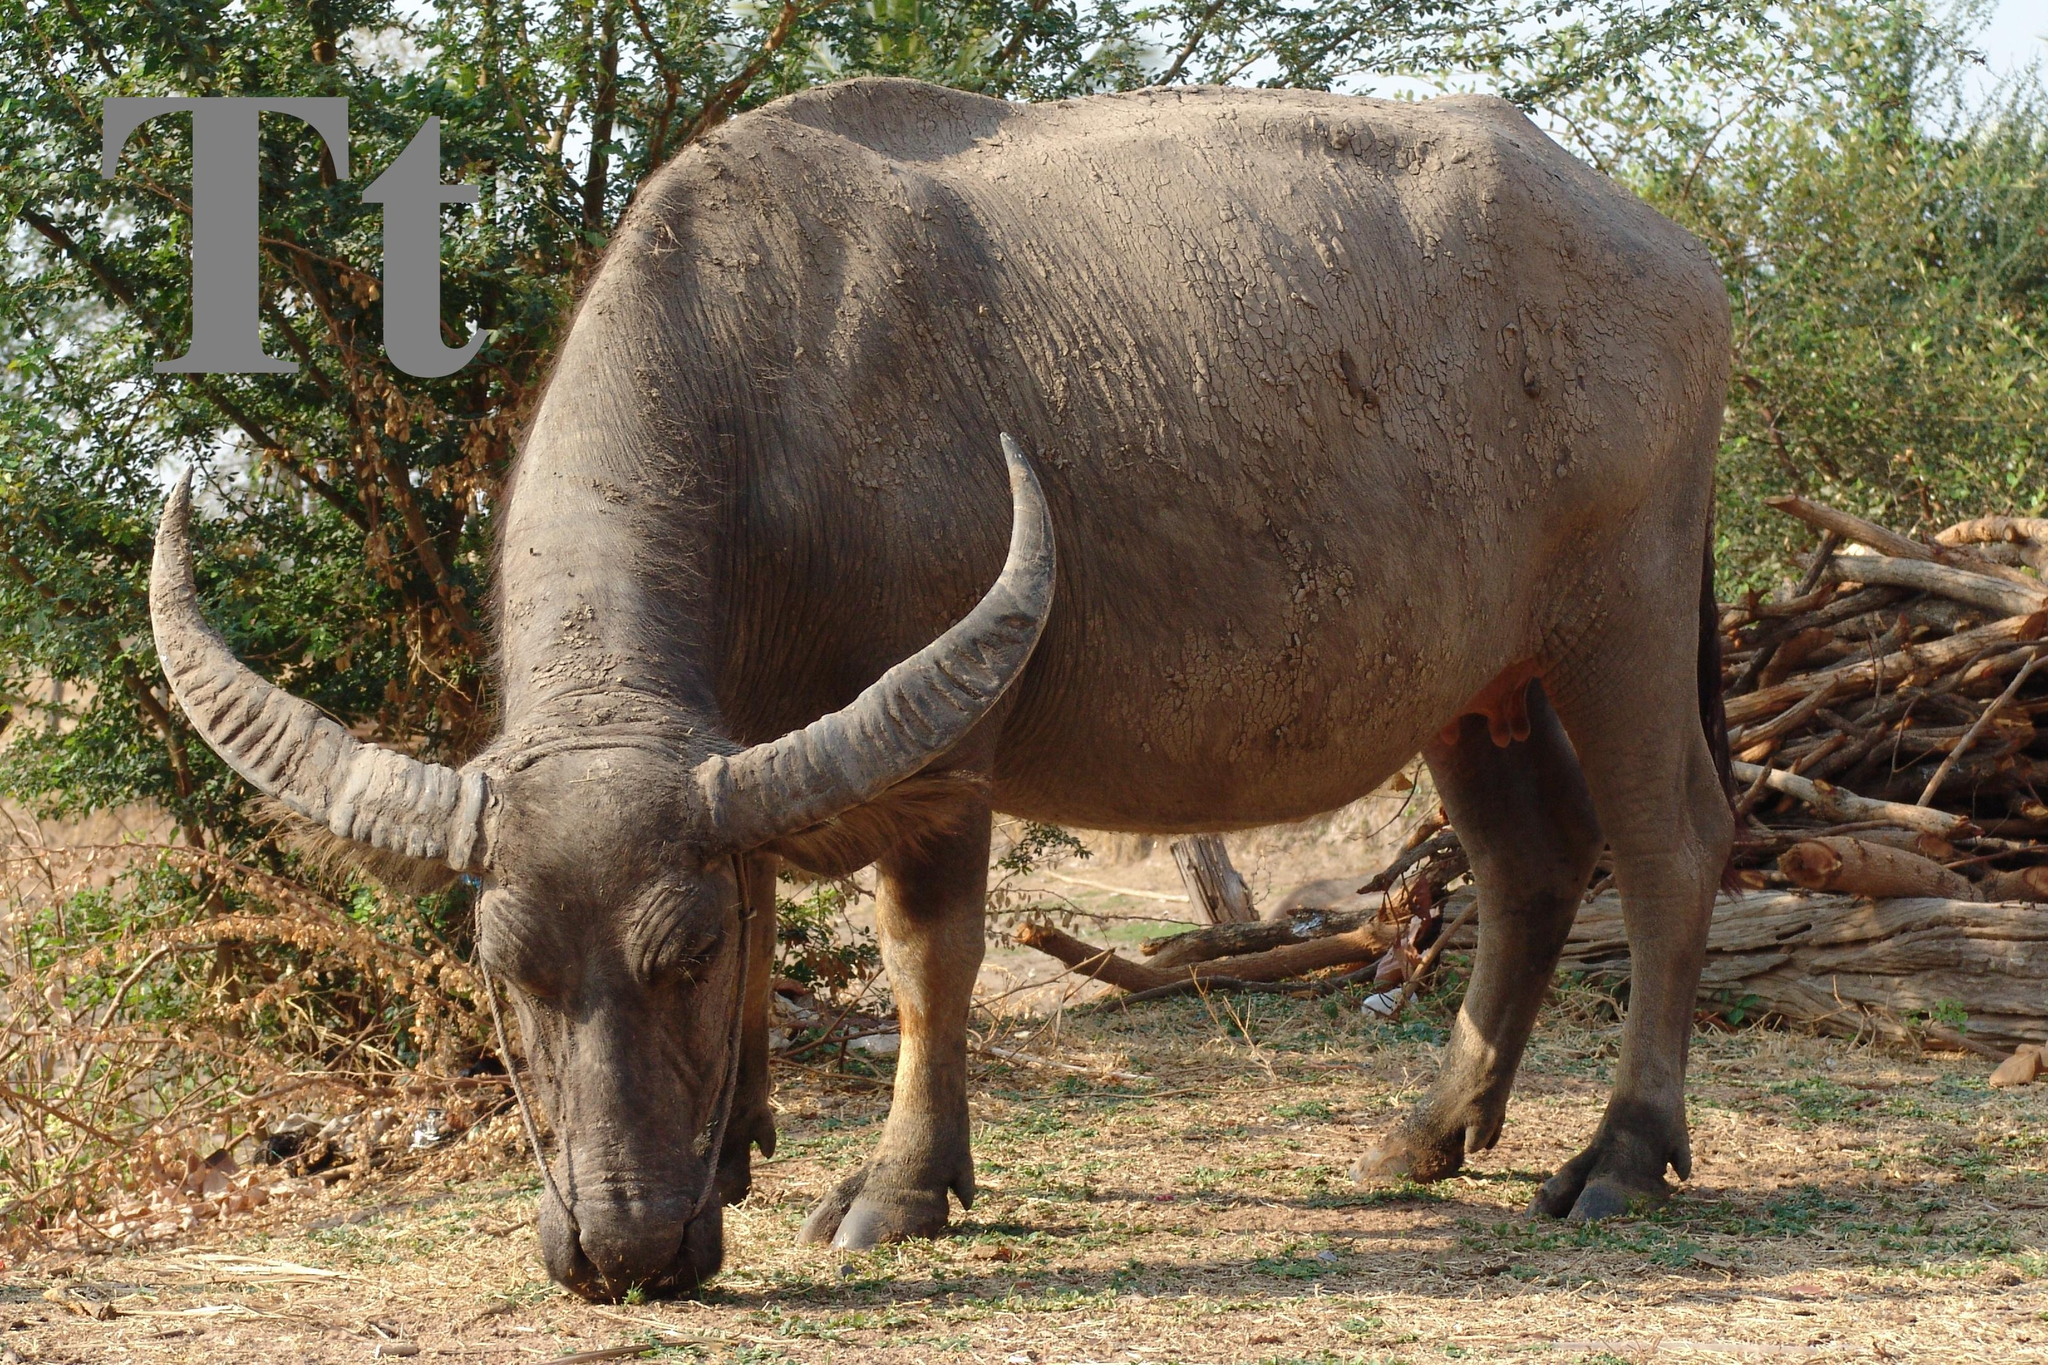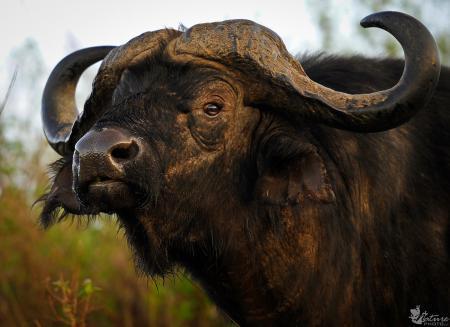The first image is the image on the left, the second image is the image on the right. Considering the images on both sides, is "One image shows at least two water buffalo in water up to their chins." valid? Answer yes or no. No. The first image is the image on the left, the second image is the image on the right. Analyze the images presented: Is the assertion "The left image contains exactly two water buffaloes." valid? Answer yes or no. No. 